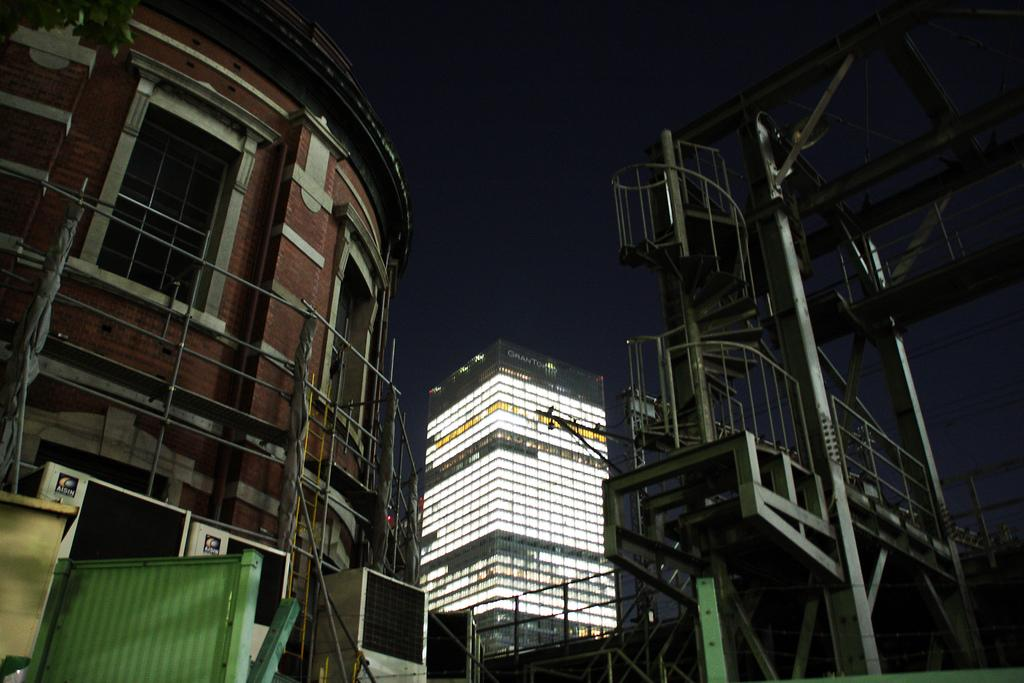What type of structures can be seen in the image? There are buildings in the image. Can you describe any architectural features in the image? Yes, there are stairs visible in the image. What is the color of the sky in the image? The sky is dark in the image. Are there any illumination sources on the buildings? Yes, there are lights on the building. How many dolls are sitting on the airport runway in the image? There are no dolls or airport runways present in the image. 